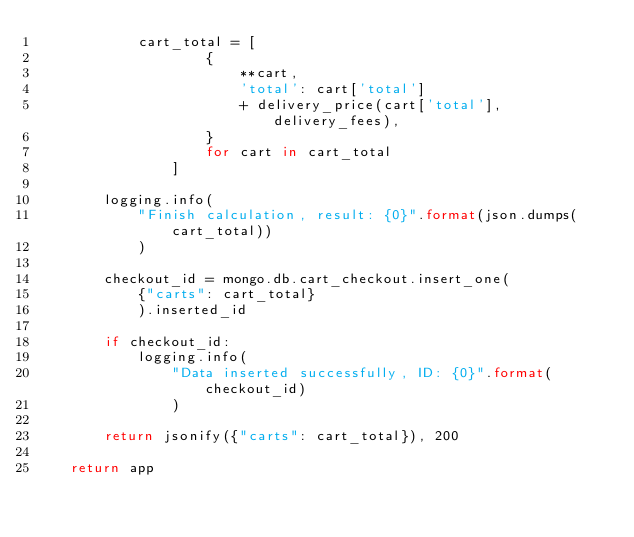<code> <loc_0><loc_0><loc_500><loc_500><_Python_>            cart_total = [
                    {
                        **cart,
                        'total': cart['total']
                        + delivery_price(cart['total'], delivery_fees),
                    }
                    for cart in cart_total
                ]

        logging.info(
            "Finish calculation, result: {0}".format(json.dumps(cart_total))
            )

        checkout_id = mongo.db.cart_checkout.insert_one(
            {"carts": cart_total}
            ).inserted_id

        if checkout_id:
            logging.info(
                "Data inserted successfully, ID: {0}".format(checkout_id)
                )

        return jsonify({"carts": cart_total}), 200

    return app
</code> 